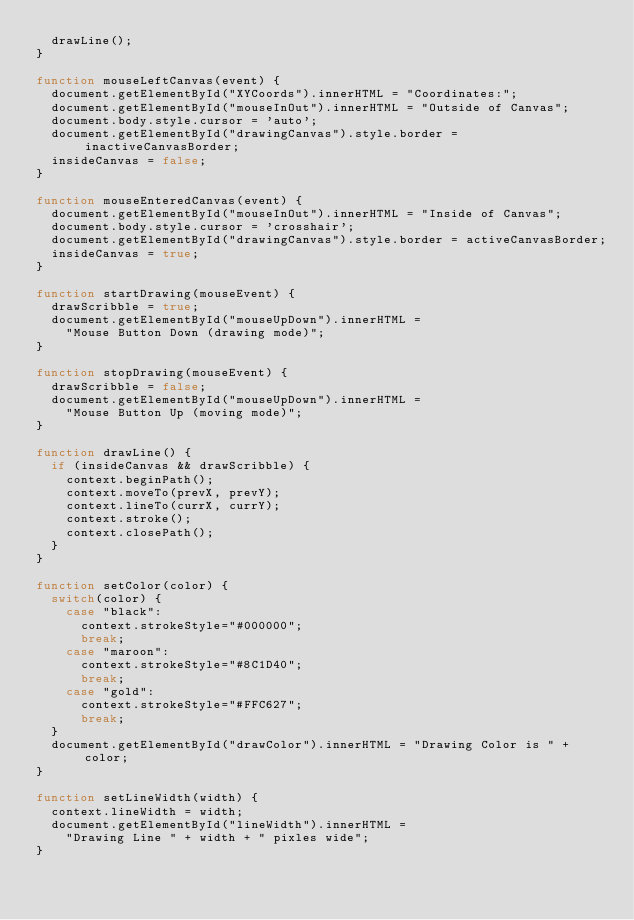Convert code to text. <code><loc_0><loc_0><loc_500><loc_500><_JavaScript_>	drawLine();
}

function mouseLeftCanvas(event) {
	document.getElementById("XYCoords").innerHTML = "Coordinates:";
	document.getElementById("mouseInOut").innerHTML = "Outside of Canvas";
	document.body.style.cursor = 'auto';
	document.getElementById("drawingCanvas").style.border = inactiveCanvasBorder;
	insideCanvas = false;
}

function mouseEnteredCanvas(event) {
	document.getElementById("mouseInOut").innerHTML = "Inside of Canvas";
	document.body.style.cursor = 'crosshair';
	document.getElementById("drawingCanvas").style.border = activeCanvasBorder;
	insideCanvas = true;
}

function startDrawing(mouseEvent) {
	drawScribble = true;
	document.getElementById("mouseUpDown").innerHTML = 
		"Mouse Button Down (drawing mode)";
}

function stopDrawing(mouseEvent) {
	drawScribble = false;
	document.getElementById("mouseUpDown").innerHTML = 
		"Mouse Button Up (moving mode)";
}

function drawLine() {
	if (insideCanvas && drawScribble) {
		context.beginPath();
		context.moveTo(prevX, prevY);
		context.lineTo(currX, currY);
		context.stroke();
		context.closePath();
	}
}

function setColor(color) {
	switch(color) {
		case "black":
			context.strokeStyle="#000000";
			break;
		case "maroon":
			context.strokeStyle="#8C1D40";
			break;
		case "gold":
			context.strokeStyle="#FFC627";
			break;
	}
	document.getElementById("drawColor").innerHTML = "Drawing Color is " + color;
}

function setLineWidth(width) {
	context.lineWidth = width;
	document.getElementById("lineWidth").innerHTML = 
		"Drawing Line " + width + " pixles wide";
}

</code> 